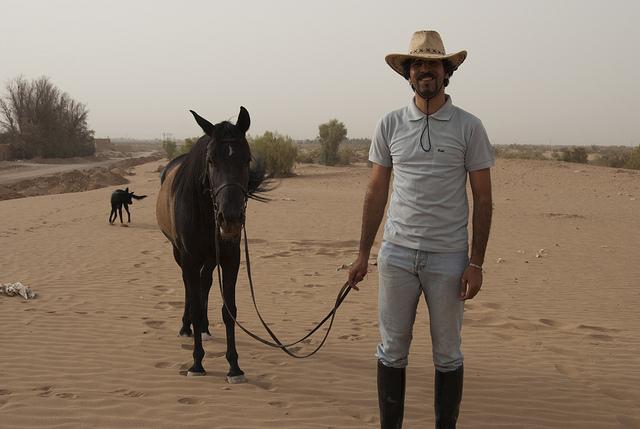Is this in the city?
Answer briefly. No. What is the man doing?
Quick response, please. Leading horse. What animals are being shown?
Keep it brief. Horse and dog. What is the dog doing in the picture?
Answer briefly. Walking. What type of boots is the man wearing?
Write a very short answer. Cowboy. Which hand holds the reins?
Write a very short answer. Right. How many different types of animals are shown?
Keep it brief. 2. Is he a tourist?
Concise answer only. No. What is the man holding onto?
Write a very short answer. Rope. What is on the man's head?
Write a very short answer. Hat. 